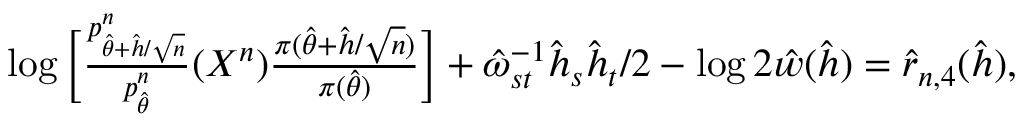<formula> <loc_0><loc_0><loc_500><loc_500>\begin{array} { r l } & { \log \left [ \frac { p _ { \hat { \theta } + \hat { h } / \sqrt { n } } ^ { n } } { p _ { \hat { \theta } } ^ { n } } ( X ^ { n } ) \frac { \pi ( \hat { \theta } + \hat { h } / \sqrt { n } ) } { \pi ( \hat { \theta } ) } \right ] + \hat { \omega } _ { s t } ^ { - 1 } \hat { h } _ { s } \hat { h } _ { t } / 2 - \log 2 \hat { w } ( \hat { h } ) = \hat { r } _ { n , 4 } ( \hat { h } ) , } \end{array}</formula> 